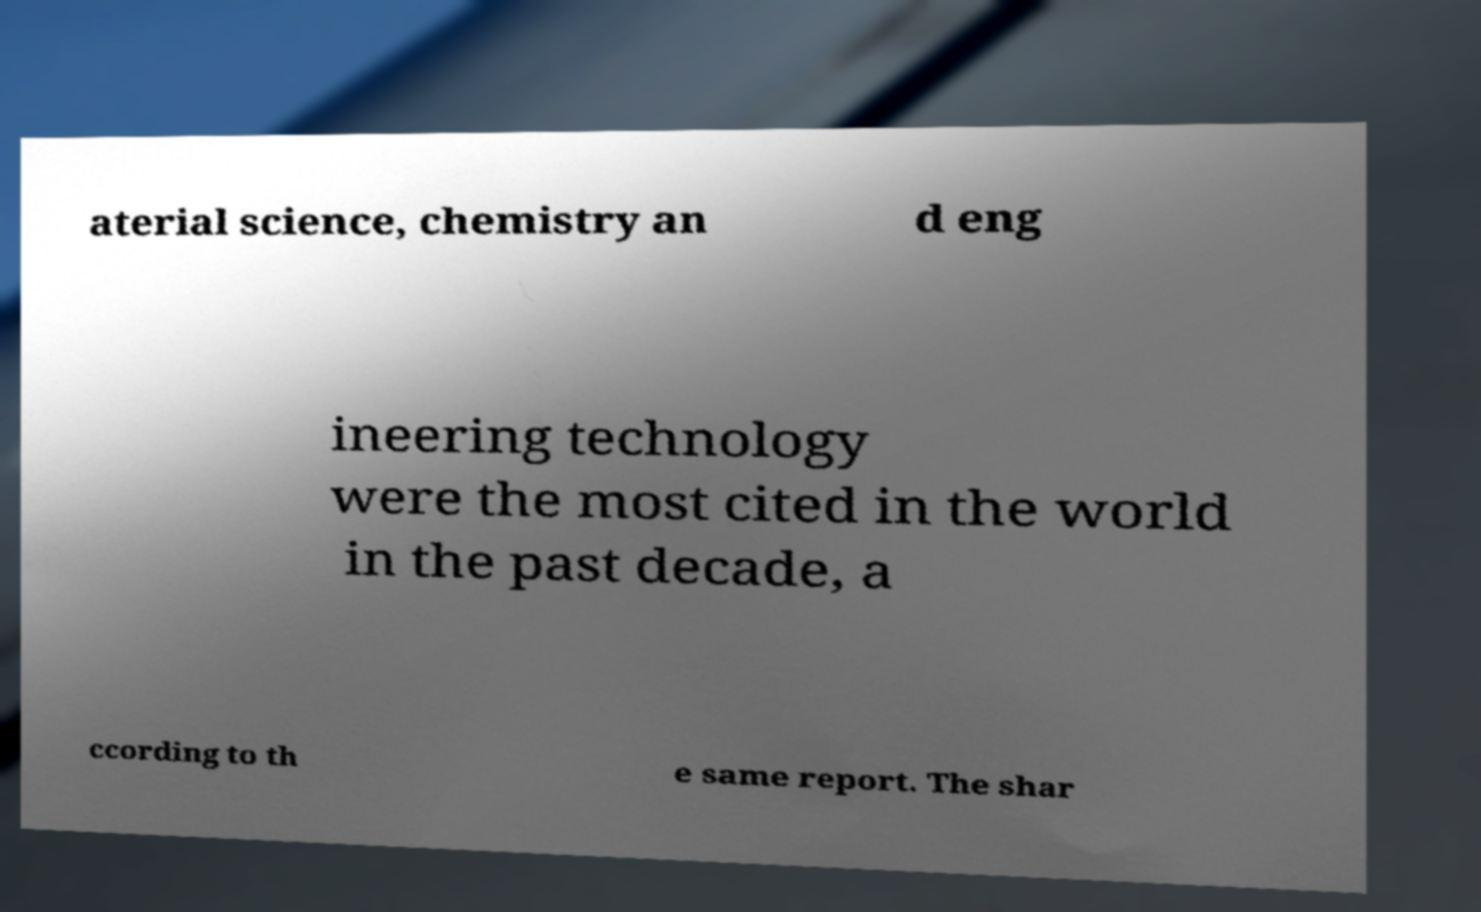Please read and relay the text visible in this image. What does it say? aterial science, chemistry an d eng ineering technology were the most cited in the world in the past decade, a ccording to th e same report. The shar 